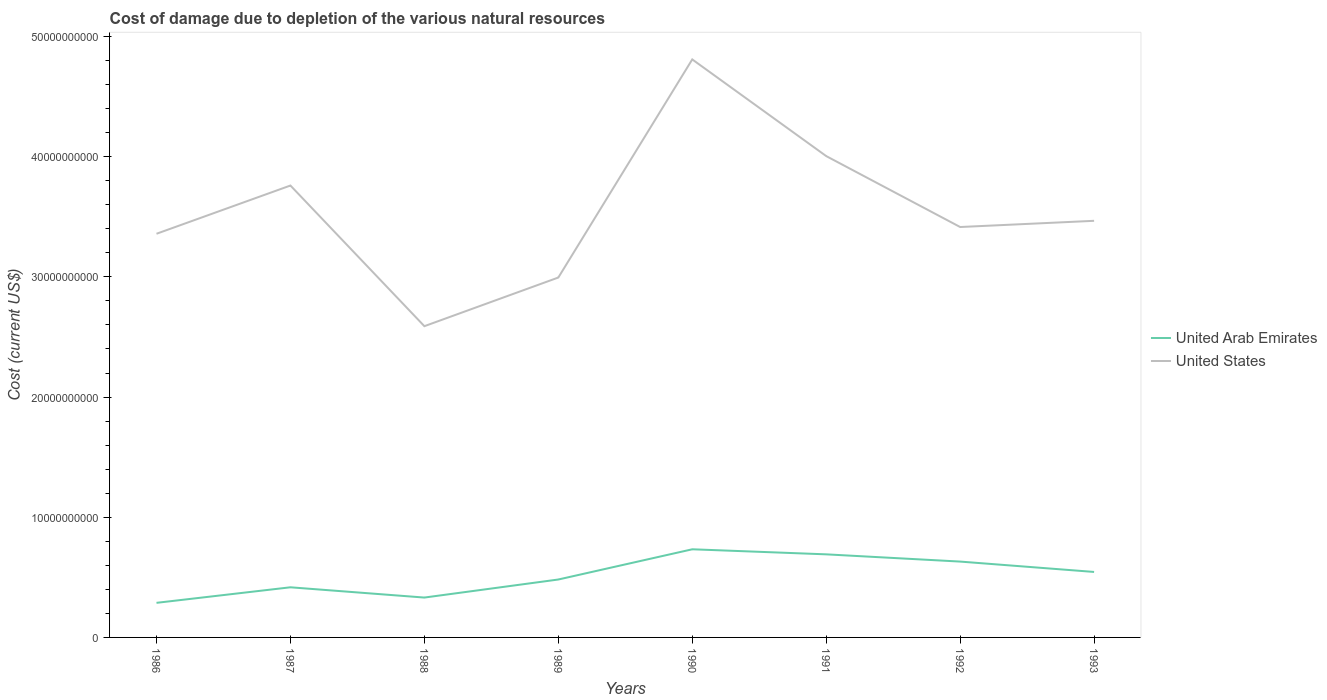How many different coloured lines are there?
Make the answer very short. 2. Across all years, what is the maximum cost of damage caused due to the depletion of various natural resources in United States?
Offer a very short reply. 2.59e+1. What is the total cost of damage caused due to the depletion of various natural resources in United States in the graph?
Provide a succinct answer. -1.42e+1. What is the difference between the highest and the second highest cost of damage caused due to the depletion of various natural resources in United States?
Make the answer very short. 2.22e+1. What is the difference between the highest and the lowest cost of damage caused due to the depletion of various natural resources in United States?
Provide a succinct answer. 3. Is the cost of damage caused due to the depletion of various natural resources in United Arab Emirates strictly greater than the cost of damage caused due to the depletion of various natural resources in United States over the years?
Your answer should be compact. Yes. How many lines are there?
Keep it short and to the point. 2. How many years are there in the graph?
Provide a short and direct response. 8. What is the difference between two consecutive major ticks on the Y-axis?
Offer a terse response. 1.00e+1. Does the graph contain any zero values?
Offer a very short reply. No. Where does the legend appear in the graph?
Provide a succinct answer. Center right. How many legend labels are there?
Keep it short and to the point. 2. How are the legend labels stacked?
Offer a very short reply. Vertical. What is the title of the graph?
Make the answer very short. Cost of damage due to depletion of the various natural resources. Does "Low & middle income" appear as one of the legend labels in the graph?
Keep it short and to the point. No. What is the label or title of the X-axis?
Give a very brief answer. Years. What is the label or title of the Y-axis?
Offer a very short reply. Cost (current US$). What is the Cost (current US$) of United Arab Emirates in 1986?
Offer a very short reply. 2.88e+09. What is the Cost (current US$) of United States in 1986?
Make the answer very short. 3.36e+1. What is the Cost (current US$) in United Arab Emirates in 1987?
Provide a succinct answer. 4.17e+09. What is the Cost (current US$) of United States in 1987?
Keep it short and to the point. 3.76e+1. What is the Cost (current US$) of United Arab Emirates in 1988?
Offer a very short reply. 3.32e+09. What is the Cost (current US$) of United States in 1988?
Ensure brevity in your answer.  2.59e+1. What is the Cost (current US$) of United Arab Emirates in 1989?
Ensure brevity in your answer.  4.82e+09. What is the Cost (current US$) of United States in 1989?
Ensure brevity in your answer.  2.99e+1. What is the Cost (current US$) of United Arab Emirates in 1990?
Your response must be concise. 7.33e+09. What is the Cost (current US$) of United States in 1990?
Provide a succinct answer. 4.81e+1. What is the Cost (current US$) of United Arab Emirates in 1991?
Offer a terse response. 6.91e+09. What is the Cost (current US$) in United States in 1991?
Offer a terse response. 4.01e+1. What is the Cost (current US$) in United Arab Emirates in 1992?
Offer a very short reply. 6.31e+09. What is the Cost (current US$) of United States in 1992?
Make the answer very short. 3.41e+1. What is the Cost (current US$) of United Arab Emirates in 1993?
Provide a short and direct response. 5.45e+09. What is the Cost (current US$) in United States in 1993?
Offer a terse response. 3.47e+1. Across all years, what is the maximum Cost (current US$) of United Arab Emirates?
Offer a very short reply. 7.33e+09. Across all years, what is the maximum Cost (current US$) in United States?
Ensure brevity in your answer.  4.81e+1. Across all years, what is the minimum Cost (current US$) in United Arab Emirates?
Provide a succinct answer. 2.88e+09. Across all years, what is the minimum Cost (current US$) in United States?
Offer a terse response. 2.59e+1. What is the total Cost (current US$) in United Arab Emirates in the graph?
Keep it short and to the point. 4.12e+1. What is the total Cost (current US$) of United States in the graph?
Offer a very short reply. 2.84e+11. What is the difference between the Cost (current US$) of United Arab Emirates in 1986 and that in 1987?
Offer a terse response. -1.29e+09. What is the difference between the Cost (current US$) in United States in 1986 and that in 1987?
Give a very brief answer. -4.01e+09. What is the difference between the Cost (current US$) in United Arab Emirates in 1986 and that in 1988?
Offer a terse response. -4.39e+08. What is the difference between the Cost (current US$) in United States in 1986 and that in 1988?
Ensure brevity in your answer.  7.69e+09. What is the difference between the Cost (current US$) in United Arab Emirates in 1986 and that in 1989?
Offer a terse response. -1.94e+09. What is the difference between the Cost (current US$) of United States in 1986 and that in 1989?
Your response must be concise. 3.64e+09. What is the difference between the Cost (current US$) in United Arab Emirates in 1986 and that in 1990?
Your answer should be compact. -4.46e+09. What is the difference between the Cost (current US$) of United States in 1986 and that in 1990?
Offer a very short reply. -1.45e+1. What is the difference between the Cost (current US$) in United Arab Emirates in 1986 and that in 1991?
Your response must be concise. -4.03e+09. What is the difference between the Cost (current US$) in United States in 1986 and that in 1991?
Offer a terse response. -6.46e+09. What is the difference between the Cost (current US$) in United Arab Emirates in 1986 and that in 1992?
Make the answer very short. -3.43e+09. What is the difference between the Cost (current US$) of United States in 1986 and that in 1992?
Ensure brevity in your answer.  -5.62e+08. What is the difference between the Cost (current US$) of United Arab Emirates in 1986 and that in 1993?
Your answer should be compact. -2.57e+09. What is the difference between the Cost (current US$) of United States in 1986 and that in 1993?
Your response must be concise. -1.08e+09. What is the difference between the Cost (current US$) in United Arab Emirates in 1987 and that in 1988?
Offer a very short reply. 8.54e+08. What is the difference between the Cost (current US$) in United States in 1987 and that in 1988?
Your answer should be very brief. 1.17e+1. What is the difference between the Cost (current US$) of United Arab Emirates in 1987 and that in 1989?
Offer a very short reply. -6.48e+08. What is the difference between the Cost (current US$) in United States in 1987 and that in 1989?
Give a very brief answer. 7.66e+09. What is the difference between the Cost (current US$) in United Arab Emirates in 1987 and that in 1990?
Give a very brief answer. -3.16e+09. What is the difference between the Cost (current US$) in United States in 1987 and that in 1990?
Make the answer very short. -1.05e+1. What is the difference between the Cost (current US$) in United Arab Emirates in 1987 and that in 1991?
Make the answer very short. -2.74e+09. What is the difference between the Cost (current US$) in United States in 1987 and that in 1991?
Provide a short and direct response. -2.45e+09. What is the difference between the Cost (current US$) in United Arab Emirates in 1987 and that in 1992?
Provide a short and direct response. -2.14e+09. What is the difference between the Cost (current US$) of United States in 1987 and that in 1992?
Offer a terse response. 3.45e+09. What is the difference between the Cost (current US$) of United Arab Emirates in 1987 and that in 1993?
Your answer should be very brief. -1.28e+09. What is the difference between the Cost (current US$) in United States in 1987 and that in 1993?
Keep it short and to the point. 2.94e+09. What is the difference between the Cost (current US$) of United Arab Emirates in 1988 and that in 1989?
Your response must be concise. -1.50e+09. What is the difference between the Cost (current US$) of United States in 1988 and that in 1989?
Make the answer very short. -4.05e+09. What is the difference between the Cost (current US$) in United Arab Emirates in 1988 and that in 1990?
Make the answer very short. -4.02e+09. What is the difference between the Cost (current US$) in United States in 1988 and that in 1990?
Offer a very short reply. -2.22e+1. What is the difference between the Cost (current US$) of United Arab Emirates in 1988 and that in 1991?
Ensure brevity in your answer.  -3.60e+09. What is the difference between the Cost (current US$) in United States in 1988 and that in 1991?
Your response must be concise. -1.42e+1. What is the difference between the Cost (current US$) in United Arab Emirates in 1988 and that in 1992?
Keep it short and to the point. -2.99e+09. What is the difference between the Cost (current US$) in United States in 1988 and that in 1992?
Provide a succinct answer. -8.25e+09. What is the difference between the Cost (current US$) in United Arab Emirates in 1988 and that in 1993?
Keep it short and to the point. -2.13e+09. What is the difference between the Cost (current US$) in United States in 1988 and that in 1993?
Your answer should be very brief. -8.77e+09. What is the difference between the Cost (current US$) in United Arab Emirates in 1989 and that in 1990?
Your response must be concise. -2.51e+09. What is the difference between the Cost (current US$) of United States in 1989 and that in 1990?
Give a very brief answer. -1.81e+1. What is the difference between the Cost (current US$) of United Arab Emirates in 1989 and that in 1991?
Your answer should be compact. -2.09e+09. What is the difference between the Cost (current US$) of United States in 1989 and that in 1991?
Your answer should be compact. -1.01e+1. What is the difference between the Cost (current US$) of United Arab Emirates in 1989 and that in 1992?
Your answer should be compact. -1.49e+09. What is the difference between the Cost (current US$) in United States in 1989 and that in 1992?
Your response must be concise. -4.20e+09. What is the difference between the Cost (current US$) in United Arab Emirates in 1989 and that in 1993?
Your response must be concise. -6.29e+08. What is the difference between the Cost (current US$) in United States in 1989 and that in 1993?
Provide a short and direct response. -4.72e+09. What is the difference between the Cost (current US$) of United Arab Emirates in 1990 and that in 1991?
Provide a succinct answer. 4.21e+08. What is the difference between the Cost (current US$) in United States in 1990 and that in 1991?
Offer a very short reply. 8.04e+09. What is the difference between the Cost (current US$) of United Arab Emirates in 1990 and that in 1992?
Give a very brief answer. 1.02e+09. What is the difference between the Cost (current US$) in United States in 1990 and that in 1992?
Offer a terse response. 1.39e+1. What is the difference between the Cost (current US$) of United Arab Emirates in 1990 and that in 1993?
Give a very brief answer. 1.89e+09. What is the difference between the Cost (current US$) in United States in 1990 and that in 1993?
Keep it short and to the point. 1.34e+1. What is the difference between the Cost (current US$) of United Arab Emirates in 1991 and that in 1992?
Your response must be concise. 6.02e+08. What is the difference between the Cost (current US$) of United States in 1991 and that in 1992?
Your response must be concise. 5.90e+09. What is the difference between the Cost (current US$) of United Arab Emirates in 1991 and that in 1993?
Your response must be concise. 1.46e+09. What is the difference between the Cost (current US$) in United States in 1991 and that in 1993?
Your answer should be very brief. 5.39e+09. What is the difference between the Cost (current US$) of United Arab Emirates in 1992 and that in 1993?
Provide a short and direct response. 8.62e+08. What is the difference between the Cost (current US$) in United States in 1992 and that in 1993?
Give a very brief answer. -5.16e+08. What is the difference between the Cost (current US$) in United Arab Emirates in 1986 and the Cost (current US$) in United States in 1987?
Your answer should be very brief. -3.47e+1. What is the difference between the Cost (current US$) in United Arab Emirates in 1986 and the Cost (current US$) in United States in 1988?
Provide a succinct answer. -2.30e+1. What is the difference between the Cost (current US$) in United Arab Emirates in 1986 and the Cost (current US$) in United States in 1989?
Ensure brevity in your answer.  -2.71e+1. What is the difference between the Cost (current US$) of United Arab Emirates in 1986 and the Cost (current US$) of United States in 1990?
Keep it short and to the point. -4.52e+1. What is the difference between the Cost (current US$) in United Arab Emirates in 1986 and the Cost (current US$) in United States in 1991?
Give a very brief answer. -3.72e+1. What is the difference between the Cost (current US$) of United Arab Emirates in 1986 and the Cost (current US$) of United States in 1992?
Keep it short and to the point. -3.13e+1. What is the difference between the Cost (current US$) in United Arab Emirates in 1986 and the Cost (current US$) in United States in 1993?
Ensure brevity in your answer.  -3.18e+1. What is the difference between the Cost (current US$) in United Arab Emirates in 1987 and the Cost (current US$) in United States in 1988?
Keep it short and to the point. -2.17e+1. What is the difference between the Cost (current US$) in United Arab Emirates in 1987 and the Cost (current US$) in United States in 1989?
Provide a short and direct response. -2.58e+1. What is the difference between the Cost (current US$) of United Arab Emirates in 1987 and the Cost (current US$) of United States in 1990?
Ensure brevity in your answer.  -4.39e+1. What is the difference between the Cost (current US$) in United Arab Emirates in 1987 and the Cost (current US$) in United States in 1991?
Your response must be concise. -3.59e+1. What is the difference between the Cost (current US$) of United Arab Emirates in 1987 and the Cost (current US$) of United States in 1992?
Give a very brief answer. -3.00e+1. What is the difference between the Cost (current US$) of United Arab Emirates in 1987 and the Cost (current US$) of United States in 1993?
Your answer should be compact. -3.05e+1. What is the difference between the Cost (current US$) in United Arab Emirates in 1988 and the Cost (current US$) in United States in 1989?
Provide a succinct answer. -2.66e+1. What is the difference between the Cost (current US$) of United Arab Emirates in 1988 and the Cost (current US$) of United States in 1990?
Offer a very short reply. -4.48e+1. What is the difference between the Cost (current US$) in United Arab Emirates in 1988 and the Cost (current US$) in United States in 1991?
Give a very brief answer. -3.67e+1. What is the difference between the Cost (current US$) in United Arab Emirates in 1988 and the Cost (current US$) in United States in 1992?
Ensure brevity in your answer.  -3.08e+1. What is the difference between the Cost (current US$) of United Arab Emirates in 1988 and the Cost (current US$) of United States in 1993?
Give a very brief answer. -3.13e+1. What is the difference between the Cost (current US$) of United Arab Emirates in 1989 and the Cost (current US$) of United States in 1990?
Keep it short and to the point. -4.33e+1. What is the difference between the Cost (current US$) of United Arab Emirates in 1989 and the Cost (current US$) of United States in 1991?
Give a very brief answer. -3.52e+1. What is the difference between the Cost (current US$) of United Arab Emirates in 1989 and the Cost (current US$) of United States in 1992?
Your response must be concise. -2.93e+1. What is the difference between the Cost (current US$) in United Arab Emirates in 1989 and the Cost (current US$) in United States in 1993?
Offer a terse response. -2.98e+1. What is the difference between the Cost (current US$) of United Arab Emirates in 1990 and the Cost (current US$) of United States in 1991?
Provide a succinct answer. -3.27e+1. What is the difference between the Cost (current US$) of United Arab Emirates in 1990 and the Cost (current US$) of United States in 1992?
Ensure brevity in your answer.  -2.68e+1. What is the difference between the Cost (current US$) in United Arab Emirates in 1990 and the Cost (current US$) in United States in 1993?
Your answer should be very brief. -2.73e+1. What is the difference between the Cost (current US$) of United Arab Emirates in 1991 and the Cost (current US$) of United States in 1992?
Offer a very short reply. -2.72e+1. What is the difference between the Cost (current US$) in United Arab Emirates in 1991 and the Cost (current US$) in United States in 1993?
Ensure brevity in your answer.  -2.78e+1. What is the difference between the Cost (current US$) in United Arab Emirates in 1992 and the Cost (current US$) in United States in 1993?
Provide a succinct answer. -2.84e+1. What is the average Cost (current US$) in United Arab Emirates per year?
Your response must be concise. 5.15e+09. What is the average Cost (current US$) of United States per year?
Provide a short and direct response. 3.55e+1. In the year 1986, what is the difference between the Cost (current US$) of United Arab Emirates and Cost (current US$) of United States?
Your response must be concise. -3.07e+1. In the year 1987, what is the difference between the Cost (current US$) in United Arab Emirates and Cost (current US$) in United States?
Give a very brief answer. -3.34e+1. In the year 1988, what is the difference between the Cost (current US$) in United Arab Emirates and Cost (current US$) in United States?
Give a very brief answer. -2.26e+1. In the year 1989, what is the difference between the Cost (current US$) of United Arab Emirates and Cost (current US$) of United States?
Your answer should be very brief. -2.51e+1. In the year 1990, what is the difference between the Cost (current US$) of United Arab Emirates and Cost (current US$) of United States?
Provide a short and direct response. -4.08e+1. In the year 1991, what is the difference between the Cost (current US$) of United Arab Emirates and Cost (current US$) of United States?
Keep it short and to the point. -3.31e+1. In the year 1992, what is the difference between the Cost (current US$) of United Arab Emirates and Cost (current US$) of United States?
Your answer should be compact. -2.78e+1. In the year 1993, what is the difference between the Cost (current US$) of United Arab Emirates and Cost (current US$) of United States?
Ensure brevity in your answer.  -2.92e+1. What is the ratio of the Cost (current US$) of United Arab Emirates in 1986 to that in 1987?
Provide a succinct answer. 0.69. What is the ratio of the Cost (current US$) of United States in 1986 to that in 1987?
Your answer should be very brief. 0.89. What is the ratio of the Cost (current US$) in United Arab Emirates in 1986 to that in 1988?
Make the answer very short. 0.87. What is the ratio of the Cost (current US$) of United States in 1986 to that in 1988?
Keep it short and to the point. 1.3. What is the ratio of the Cost (current US$) of United Arab Emirates in 1986 to that in 1989?
Provide a succinct answer. 0.6. What is the ratio of the Cost (current US$) in United States in 1986 to that in 1989?
Offer a terse response. 1.12. What is the ratio of the Cost (current US$) of United Arab Emirates in 1986 to that in 1990?
Keep it short and to the point. 0.39. What is the ratio of the Cost (current US$) in United States in 1986 to that in 1990?
Make the answer very short. 0.7. What is the ratio of the Cost (current US$) of United Arab Emirates in 1986 to that in 1991?
Provide a succinct answer. 0.42. What is the ratio of the Cost (current US$) of United States in 1986 to that in 1991?
Ensure brevity in your answer.  0.84. What is the ratio of the Cost (current US$) of United Arab Emirates in 1986 to that in 1992?
Make the answer very short. 0.46. What is the ratio of the Cost (current US$) of United States in 1986 to that in 1992?
Provide a short and direct response. 0.98. What is the ratio of the Cost (current US$) in United Arab Emirates in 1986 to that in 1993?
Make the answer very short. 0.53. What is the ratio of the Cost (current US$) of United States in 1986 to that in 1993?
Keep it short and to the point. 0.97. What is the ratio of the Cost (current US$) in United Arab Emirates in 1987 to that in 1988?
Ensure brevity in your answer.  1.26. What is the ratio of the Cost (current US$) of United States in 1987 to that in 1988?
Your answer should be very brief. 1.45. What is the ratio of the Cost (current US$) of United Arab Emirates in 1987 to that in 1989?
Ensure brevity in your answer.  0.87. What is the ratio of the Cost (current US$) of United States in 1987 to that in 1989?
Offer a terse response. 1.26. What is the ratio of the Cost (current US$) of United Arab Emirates in 1987 to that in 1990?
Make the answer very short. 0.57. What is the ratio of the Cost (current US$) of United States in 1987 to that in 1990?
Give a very brief answer. 0.78. What is the ratio of the Cost (current US$) of United Arab Emirates in 1987 to that in 1991?
Offer a very short reply. 0.6. What is the ratio of the Cost (current US$) of United States in 1987 to that in 1991?
Your answer should be compact. 0.94. What is the ratio of the Cost (current US$) in United Arab Emirates in 1987 to that in 1992?
Give a very brief answer. 0.66. What is the ratio of the Cost (current US$) of United States in 1987 to that in 1992?
Your answer should be compact. 1.1. What is the ratio of the Cost (current US$) of United Arab Emirates in 1987 to that in 1993?
Provide a succinct answer. 0.77. What is the ratio of the Cost (current US$) in United States in 1987 to that in 1993?
Keep it short and to the point. 1.08. What is the ratio of the Cost (current US$) in United Arab Emirates in 1988 to that in 1989?
Your answer should be very brief. 0.69. What is the ratio of the Cost (current US$) in United States in 1988 to that in 1989?
Make the answer very short. 0.86. What is the ratio of the Cost (current US$) of United Arab Emirates in 1988 to that in 1990?
Provide a succinct answer. 0.45. What is the ratio of the Cost (current US$) of United States in 1988 to that in 1990?
Offer a very short reply. 0.54. What is the ratio of the Cost (current US$) of United Arab Emirates in 1988 to that in 1991?
Keep it short and to the point. 0.48. What is the ratio of the Cost (current US$) of United States in 1988 to that in 1991?
Offer a terse response. 0.65. What is the ratio of the Cost (current US$) of United Arab Emirates in 1988 to that in 1992?
Offer a very short reply. 0.53. What is the ratio of the Cost (current US$) of United States in 1988 to that in 1992?
Keep it short and to the point. 0.76. What is the ratio of the Cost (current US$) of United Arab Emirates in 1988 to that in 1993?
Keep it short and to the point. 0.61. What is the ratio of the Cost (current US$) in United States in 1988 to that in 1993?
Provide a succinct answer. 0.75. What is the ratio of the Cost (current US$) in United Arab Emirates in 1989 to that in 1990?
Provide a succinct answer. 0.66. What is the ratio of the Cost (current US$) of United States in 1989 to that in 1990?
Offer a terse response. 0.62. What is the ratio of the Cost (current US$) in United Arab Emirates in 1989 to that in 1991?
Provide a short and direct response. 0.7. What is the ratio of the Cost (current US$) in United States in 1989 to that in 1991?
Keep it short and to the point. 0.75. What is the ratio of the Cost (current US$) in United Arab Emirates in 1989 to that in 1992?
Offer a terse response. 0.76. What is the ratio of the Cost (current US$) of United States in 1989 to that in 1992?
Make the answer very short. 0.88. What is the ratio of the Cost (current US$) of United Arab Emirates in 1989 to that in 1993?
Your answer should be very brief. 0.88. What is the ratio of the Cost (current US$) of United States in 1989 to that in 1993?
Keep it short and to the point. 0.86. What is the ratio of the Cost (current US$) of United Arab Emirates in 1990 to that in 1991?
Provide a short and direct response. 1.06. What is the ratio of the Cost (current US$) in United States in 1990 to that in 1991?
Your answer should be compact. 1.2. What is the ratio of the Cost (current US$) in United Arab Emirates in 1990 to that in 1992?
Your response must be concise. 1.16. What is the ratio of the Cost (current US$) of United States in 1990 to that in 1992?
Provide a succinct answer. 1.41. What is the ratio of the Cost (current US$) in United Arab Emirates in 1990 to that in 1993?
Provide a succinct answer. 1.35. What is the ratio of the Cost (current US$) of United States in 1990 to that in 1993?
Keep it short and to the point. 1.39. What is the ratio of the Cost (current US$) in United Arab Emirates in 1991 to that in 1992?
Your answer should be very brief. 1.1. What is the ratio of the Cost (current US$) of United States in 1991 to that in 1992?
Your answer should be compact. 1.17. What is the ratio of the Cost (current US$) in United Arab Emirates in 1991 to that in 1993?
Offer a terse response. 1.27. What is the ratio of the Cost (current US$) in United States in 1991 to that in 1993?
Give a very brief answer. 1.16. What is the ratio of the Cost (current US$) in United Arab Emirates in 1992 to that in 1993?
Your answer should be very brief. 1.16. What is the ratio of the Cost (current US$) of United States in 1992 to that in 1993?
Give a very brief answer. 0.99. What is the difference between the highest and the second highest Cost (current US$) in United Arab Emirates?
Make the answer very short. 4.21e+08. What is the difference between the highest and the second highest Cost (current US$) of United States?
Give a very brief answer. 8.04e+09. What is the difference between the highest and the lowest Cost (current US$) of United Arab Emirates?
Provide a short and direct response. 4.46e+09. What is the difference between the highest and the lowest Cost (current US$) of United States?
Provide a short and direct response. 2.22e+1. 